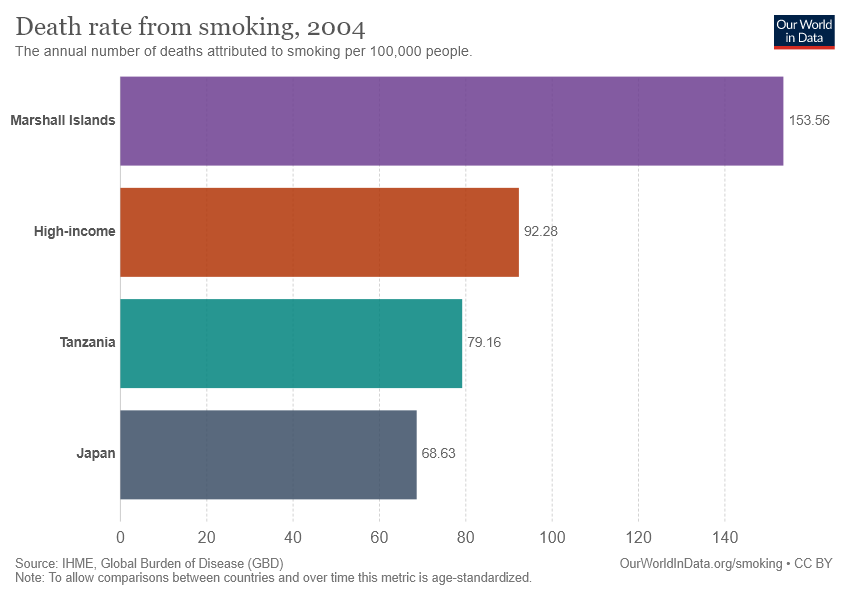Draw attention to some important aspects in this diagram. The value of the longest bar is 153.56... The average of the smallest two bars is 73.895. 